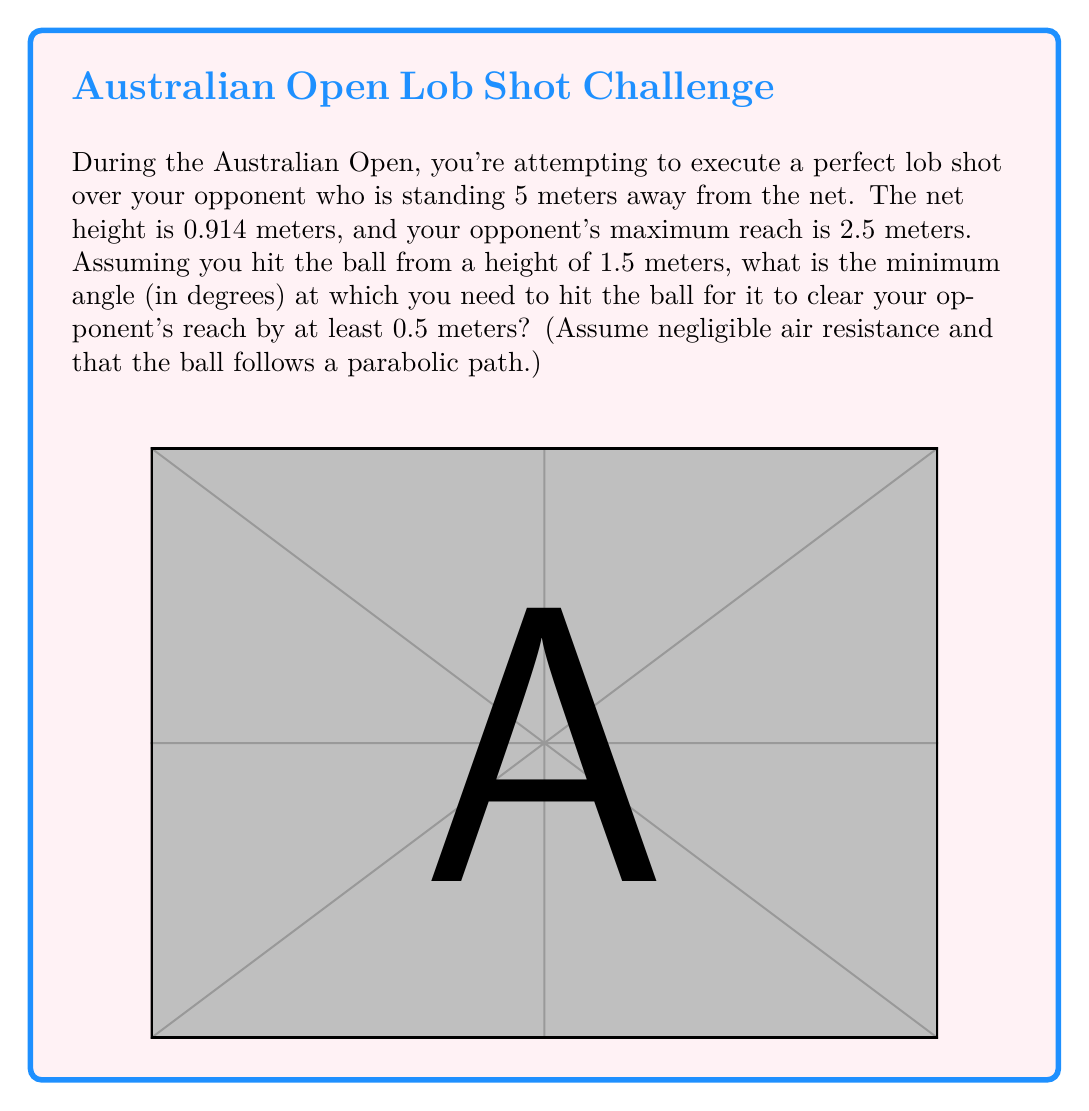Can you solve this math problem? Let's approach this step-by-step:

1) First, we need to determine the height the ball needs to reach at the opponent's position. This is:
   $2.5 \text{ m (opponent's reach)} + 0.5 \text{ m (clearance)} = 3 \text{ m}$

2) We can treat this as a projectile motion problem. The trajectory of the ball forms a parabola, and we need to find the angle that will make the ball reach a height of 3 m when it's 5 m away horizontally.

3) The equation for the height of a projectile at any given point is:
   $y = \tan(\theta) \cdot x - \frac{g}{2v_0^2\cos^2(\theta)} \cdot x^2 + y_0$

   Where:
   $y$ is the height at any point x
   $\theta$ is the launch angle
   $x$ is the horizontal distance
   $g$ is the acceleration due to gravity (9.8 m/s²)
   $v_0$ is the initial velocity
   $y_0$ is the initial height

4) We don't know the initial velocity, but we can eliminate it by using the fact that the ball needs to reach a height of 3 m when x = 5 m:

   $3 = 5\tan(\theta) - \frac{5^2g}{2v_0^2\cos^2(\theta)} + 1.5$

5) We can simplify this to:
   $1.5 = 5\tan(\theta) - \frac{25g}{2v_0^2\cos^2(\theta)}$

6) The minimum angle will occur when the ball just barely reaches 3 m at x = 5 m. This happens when the vertex of the parabola is at x = 5 m. In this case, the two terms on the right side of the equation are equal:

   $5\tan(\theta) = \frac{25g}{2v_0^2\cos^2(\theta)} = 0.75$

7) From this, we can derive:
   $\tan(\theta) = 0.15$

8) Taking the inverse tangent of both sides:
   $\theta = \tan^{-1}(0.15)$

9) Converting to degrees:
   $\theta = \tan^{-1}(0.15) \cdot \frac{180}{\pi} \approx 8.53°$
Answer: The minimum angle at which you need to hit the ball is approximately $8.53°$. 